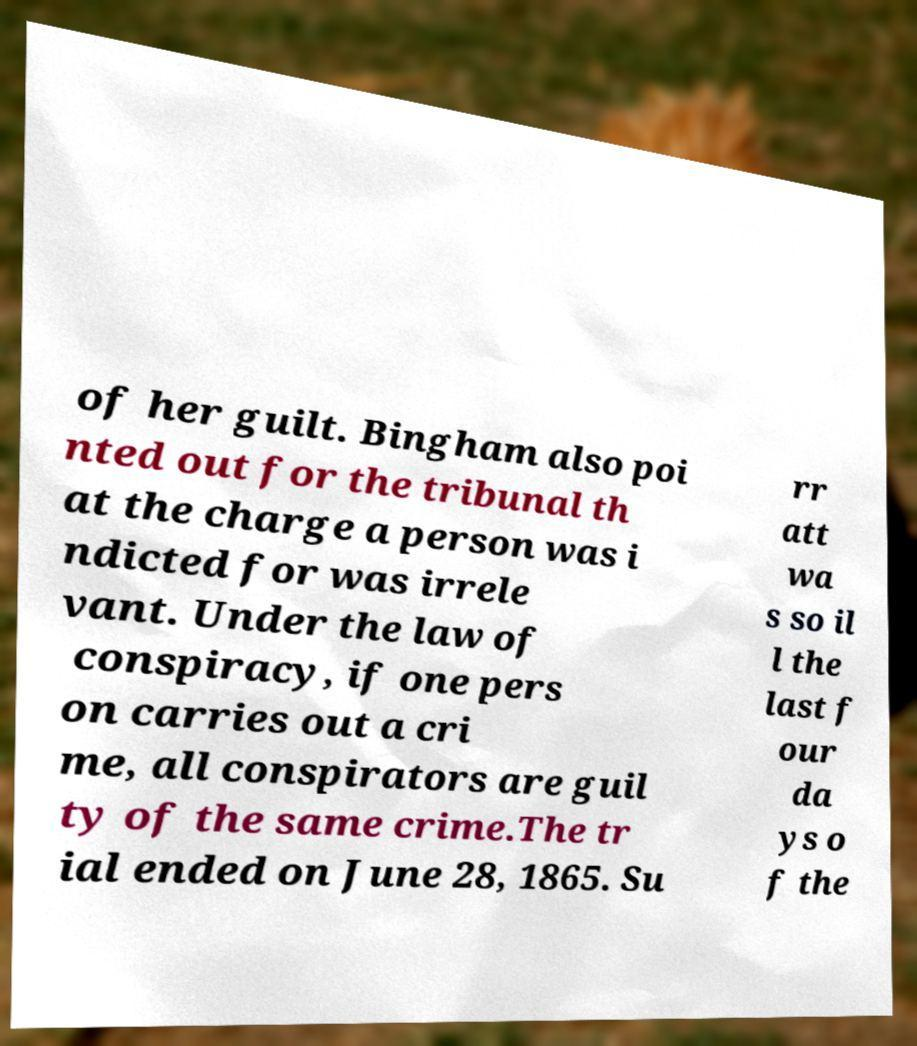What messages or text are displayed in this image? I need them in a readable, typed format. of her guilt. Bingham also poi nted out for the tribunal th at the charge a person was i ndicted for was irrele vant. Under the law of conspiracy, if one pers on carries out a cri me, all conspirators are guil ty of the same crime.The tr ial ended on June 28, 1865. Su rr att wa s so il l the last f our da ys o f the 